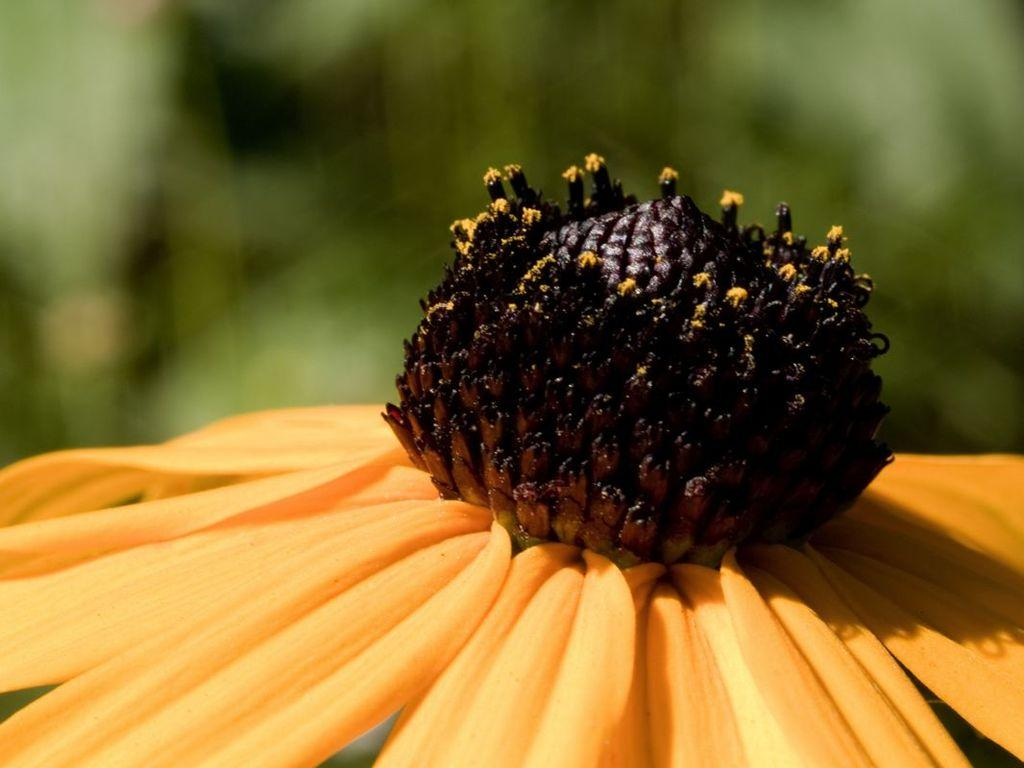What is located at the bottom of the image? There is a flower and a field at the bottom of the image. What type of vegetation can be seen in the field? The provided facts do not specify the type of vegetation in the field. What can be seen in the background of the image? There is greenery in the background of the image. What is the flower thinking about in the image? The provided facts do not give any information about the flower's thoughts or mental state. How many plants are present in the image? The provided facts only mention a flower and greenery in the background, but they do not specify the number of plants. 